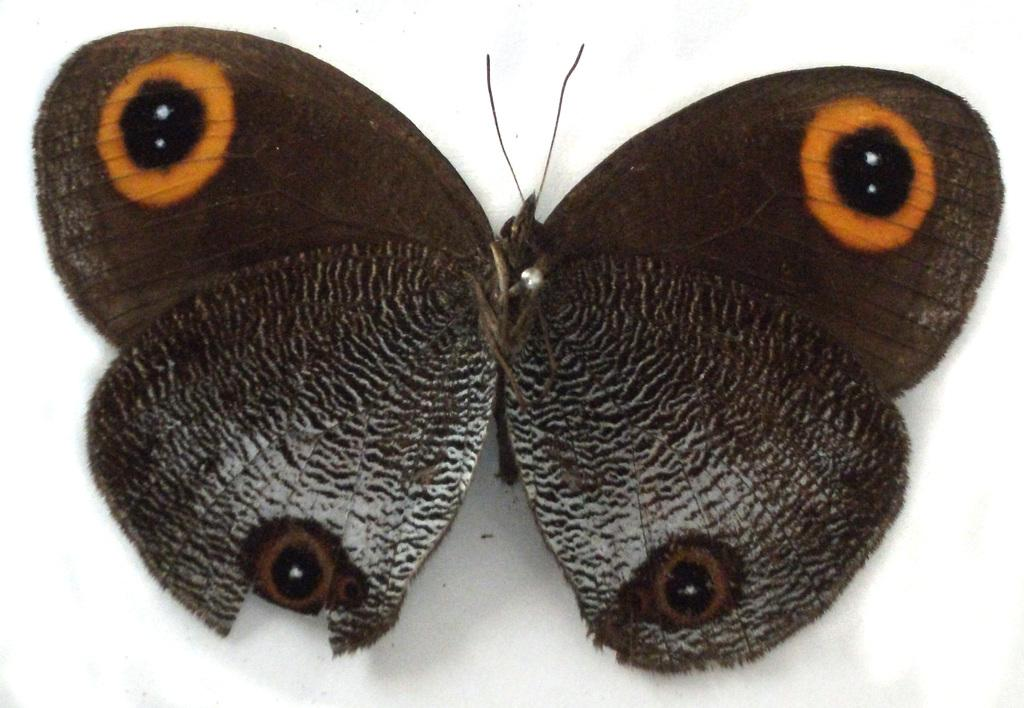What is the main subject of the image? There is a butterfly in the image. What can be seen in the background of the image? There is a white surface in the background of the image. What type of can is visible in the image? There is no can present in the image; it features a butterfly and a white surface. What stage of development is the butterfly in the image? The stage of development of the butterfly cannot be determined from the image alone. 